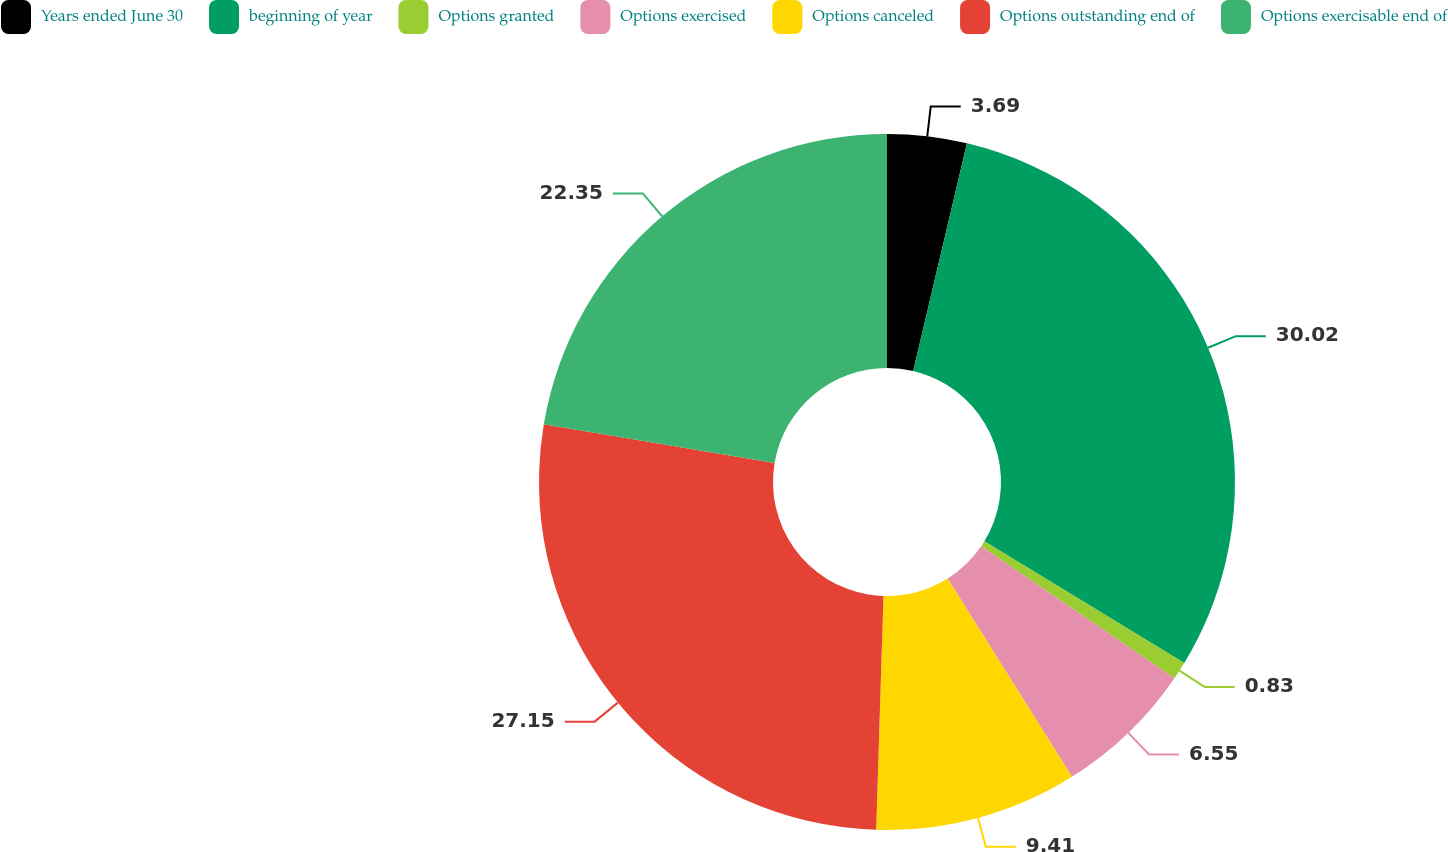Convert chart to OTSL. <chart><loc_0><loc_0><loc_500><loc_500><pie_chart><fcel>Years ended June 30<fcel>beginning of year<fcel>Options granted<fcel>Options exercised<fcel>Options canceled<fcel>Options outstanding end of<fcel>Options exercisable end of<nl><fcel>3.69%<fcel>30.01%<fcel>0.83%<fcel>6.55%<fcel>9.41%<fcel>27.15%<fcel>22.35%<nl></chart> 